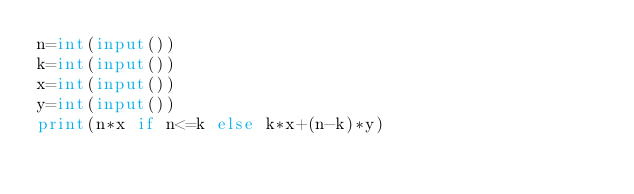Convert code to text. <code><loc_0><loc_0><loc_500><loc_500><_Python_>n=int(input())
k=int(input())
x=int(input())
y=int(input())
print(n*x if n<=k else k*x+(n-k)*y)</code> 